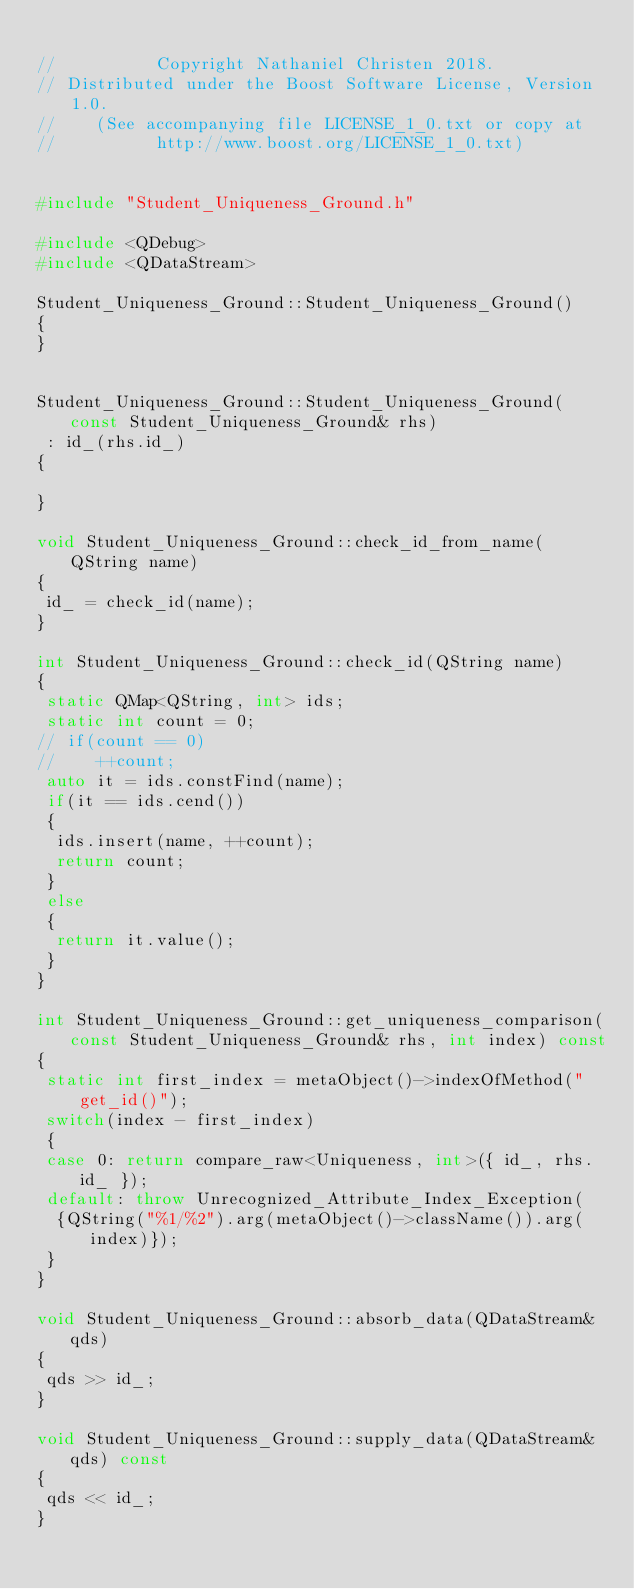Convert code to text. <code><loc_0><loc_0><loc_500><loc_500><_C++_>
//          Copyright Nathaniel Christen 2018.
// Distributed under the Boost Software License, Version 1.0.
//    (See accompanying file LICENSE_1_0.txt or copy at
//          http://www.boost.org/LICENSE_1_0.txt)


#include "Student_Uniqueness_Ground.h"

#include <QDebug>
#include <QDataStream>

Student_Uniqueness_Ground::Student_Uniqueness_Ground()
{
}


Student_Uniqueness_Ground::Student_Uniqueness_Ground(const Student_Uniqueness_Ground& rhs)
 : id_(rhs.id_)
{

}

void Student_Uniqueness_Ground::check_id_from_name(QString name)
{
 id_ = check_id(name);
}

int Student_Uniqueness_Ground::check_id(QString name)
{
 static QMap<QString, int> ids;
 static int count = 0;
// if(count == 0)
//    ++count;
 auto it = ids.constFind(name);
 if(it == ids.cend())
 {
  ids.insert(name, ++count);
  return count;
 }
 else
 {
  return it.value();
 }
}

int Student_Uniqueness_Ground::get_uniqueness_comparison(const Student_Uniqueness_Ground& rhs, int index) const
{
 static int first_index = metaObject()->indexOfMethod("get_id()");
 switch(index - first_index)
 {
 case 0: return compare_raw<Uniqueness, int>({ id_, rhs.id_ });
 default: throw Unrecognized_Attribute_Index_Exception(
  {QString("%1/%2").arg(metaObject()->className()).arg(index)});
 }
}

void Student_Uniqueness_Ground::absorb_data(QDataStream& qds)
{
 qds >> id_;
}

void Student_Uniqueness_Ground::supply_data(QDataStream& qds) const
{
 qds << id_;
}



</code> 